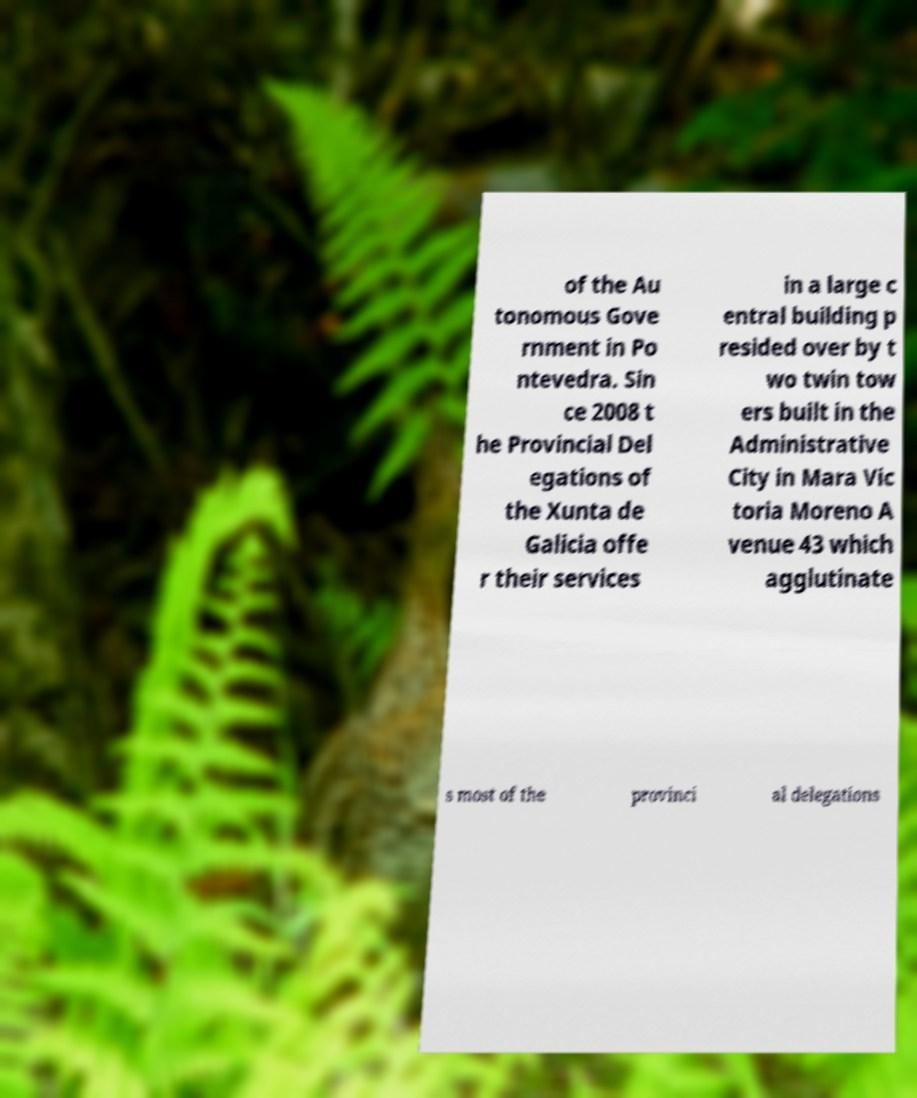Can you accurately transcribe the text from the provided image for me? of the Au tonomous Gove rnment in Po ntevedra. Sin ce 2008 t he Provincial Del egations of the Xunta de Galicia offe r their services in a large c entral building p resided over by t wo twin tow ers built in the Administrative City in Mara Vic toria Moreno A venue 43 which agglutinate s most of the provinci al delegations 